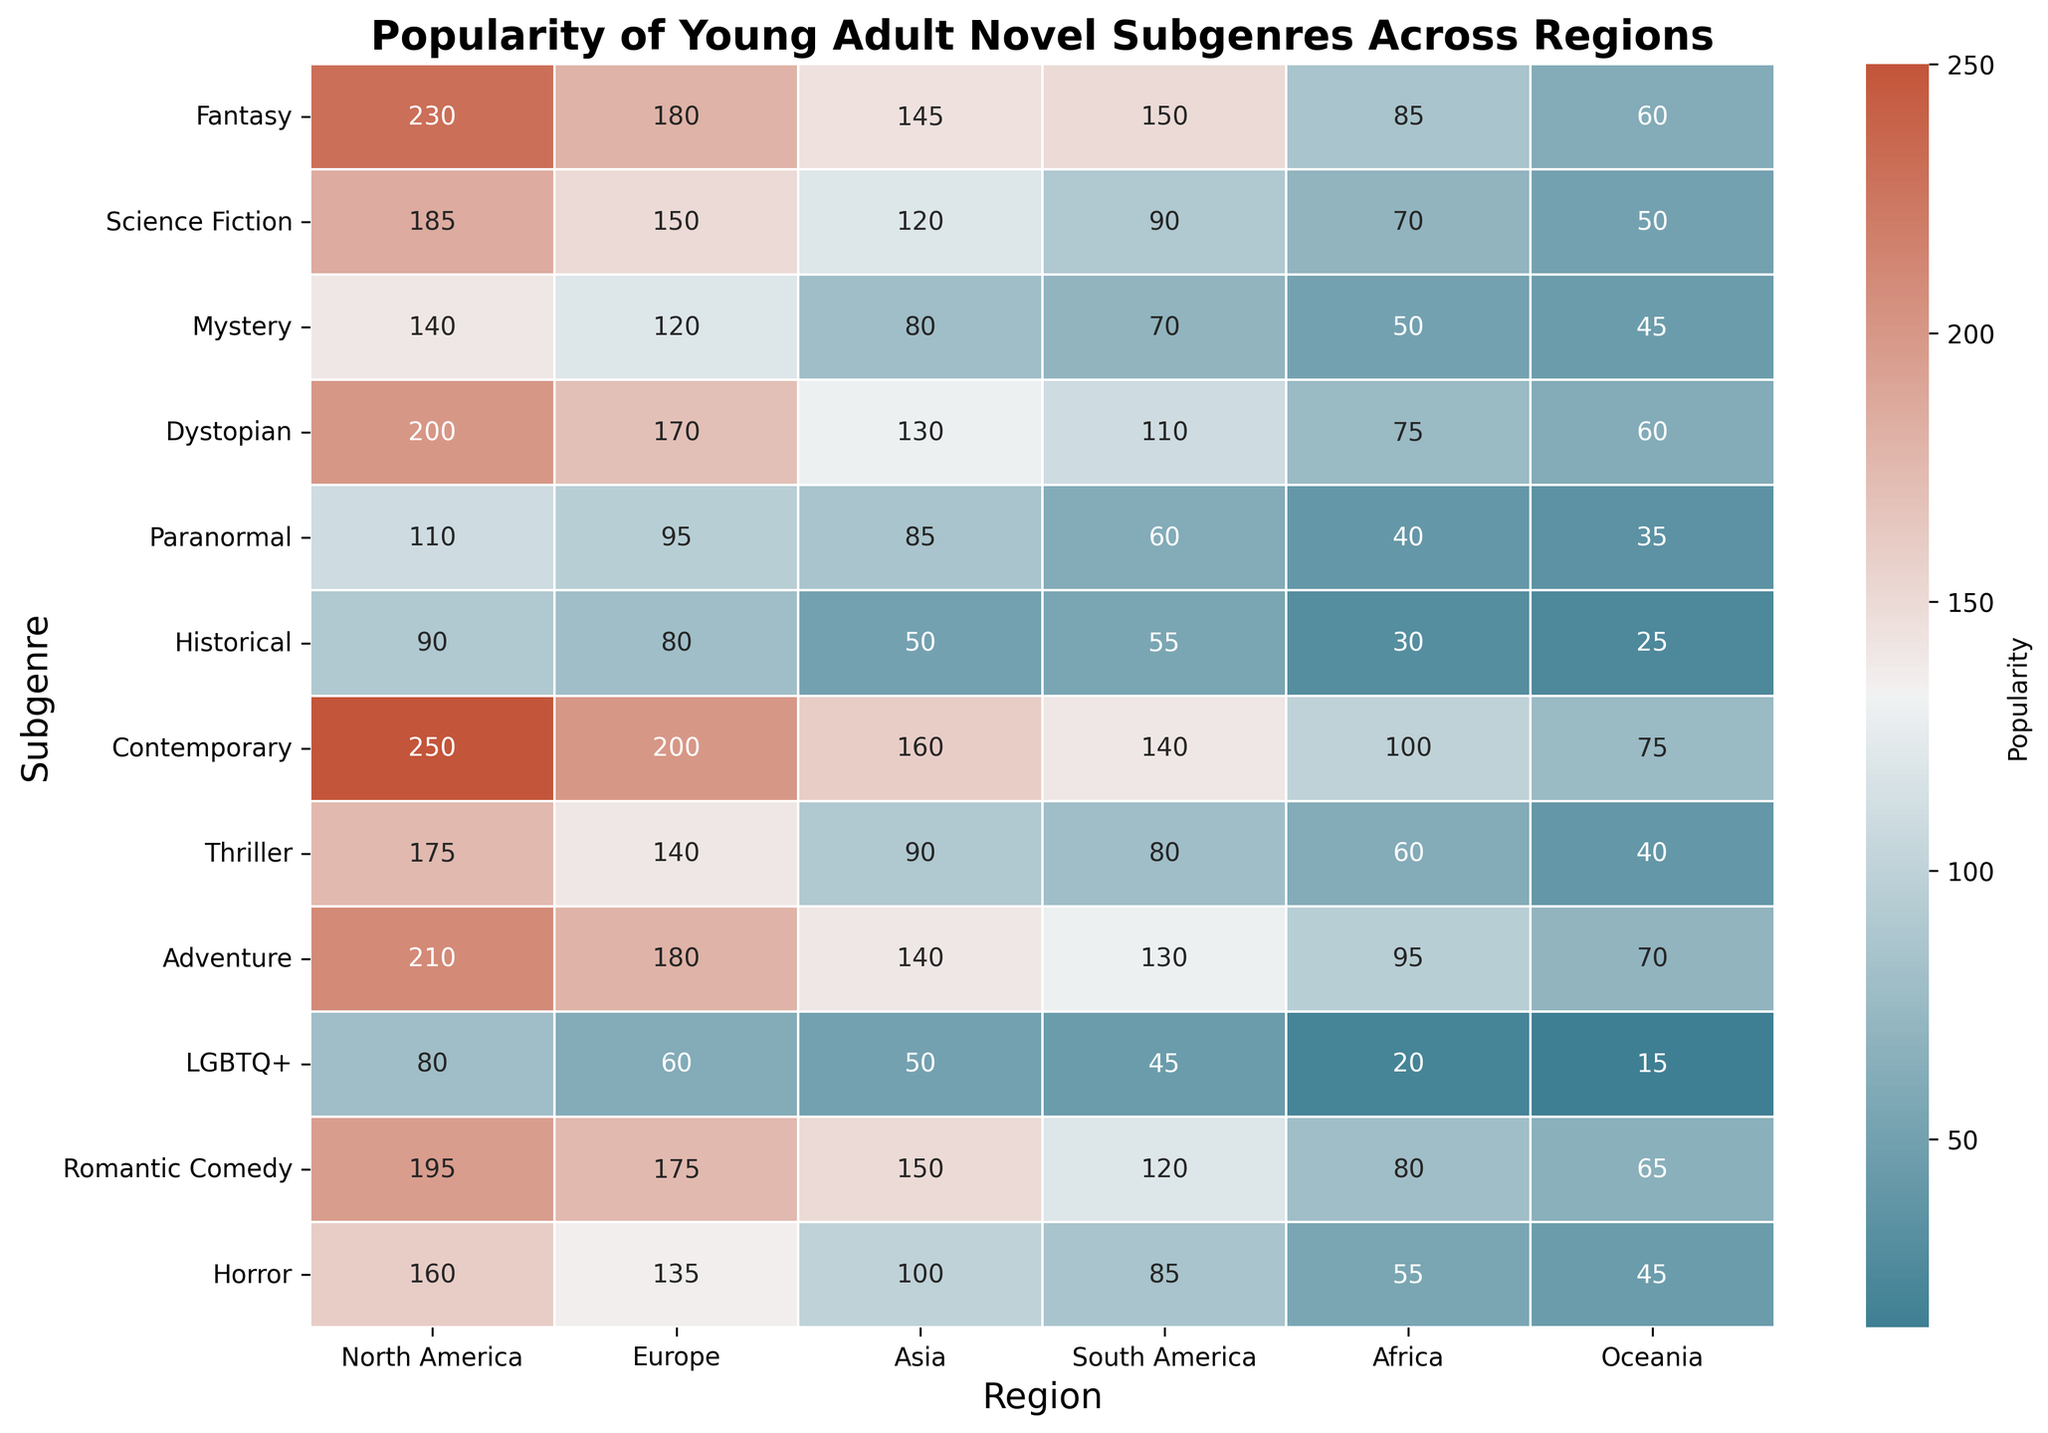Which subgenre is least popular in Oceania? Look at the values in the Oceania column and identify the lowest one. The lowest value is in the LGBTQ+ row.
Answer: LGBTQ+ How does the popularity of Fantasy in North America compare to that in Europe? Compare the values in the Fantasy row for North America and Europe. In North America, it's 230, and in Europe, it's 180.
Answer: North America is higher What’s the total popularity of Historical fiction across all regions? Sum the values in the Historical row: 90 + 80 + 50 + 55 + 30 + 25. The total is 330.
Answer: 330 Which region has the highest popularity for Contemporary novels? Find the highest value in the Contemporary row. The highest value is in North America with 250.
Answer: North America Is Science Fiction more or less popular than Fantasy in Asia? Compare the values in the Science Fiction and Fantasy rows for Asia. Science Fiction has 120, and Fantasy has 145.
Answer: Less popular Compare the popularity of Romantic Comedy and Horror in South America. Which is more popular? Look at the values in the Romantic Comedy and Horror rows for South America. Romantic Comedy has 120, and Horror has 85.
Answer: Romantic Comedy is more popular Which subgenre has the closest popularity values in North America and Europe? Calculate the differences between North America and Europe for each subgenre. Romantic Comedy has 195 in North America and 175 in Europe, with a difference of 20—the smallest difference.
Answer: Romantic Comedy What is the average popularity of Adventure novels across all regions? Calculate the sum of Adventure values: 210 + 180 + 140 + 130 + 95 + 70 = 825. Divide by the number of regions (6). The average is 825/6 = 137.5.
Answer: 137.5 In which region is the Paranormal subgenre most popular? Find the highest value in the Paranormal row. The highest value is in North America with 110.
Answer: North America What subgenre has the most significant difference in popularity between North America and Africa? Calculate the differences for each subgenre between North America and Africa. Contemporary has the largest difference (250 in North America, 100 in Africa), which is 150.
Answer: Contemporary 